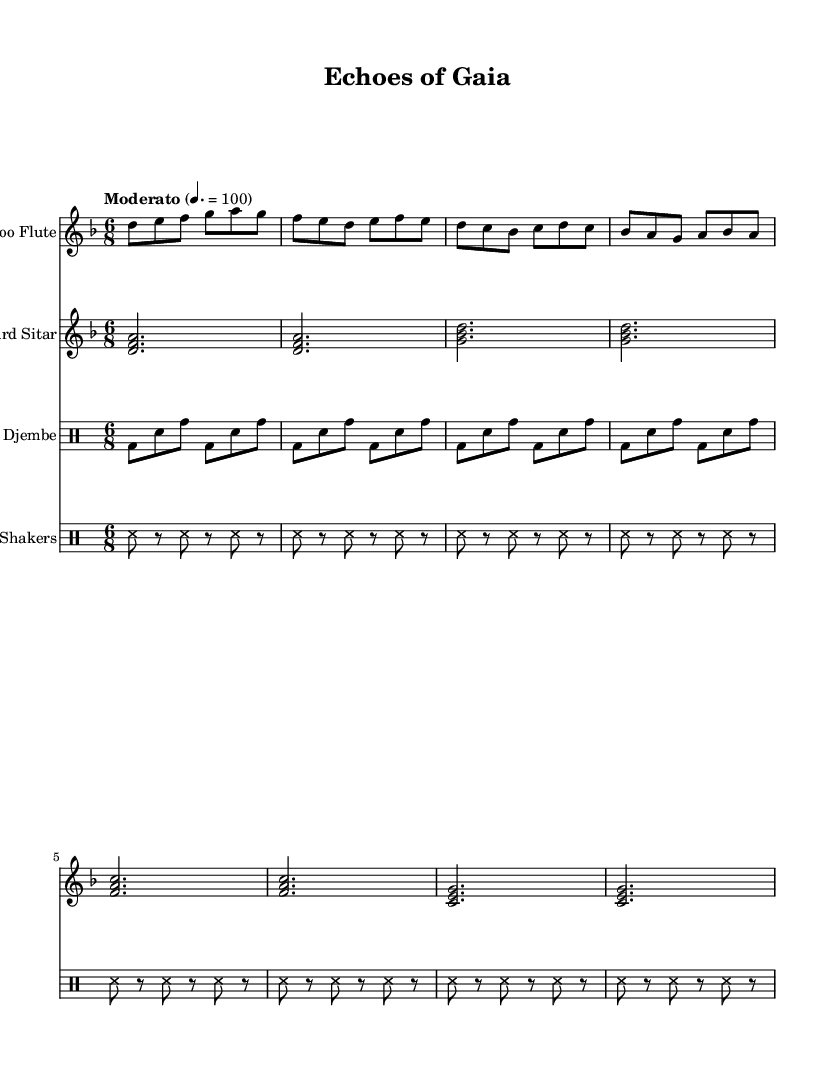What is the key signature of this music? The key signature is indicated at the beginning of the score, and it shows one flat (B♭). This identifies the key as D minor.
Answer: D minor What is the time signature of this music? The time signature is shown at the beginning of the score as 6/8, which means there are 6 beats per measure with an eighth note receiving one beat.
Answer: 6/8 What tempo marking is used in this piece? The tempo marking is located next to the global setup and reads "Moderato" with a metronome marking of 100 beats per minute, indicating the speed of the piece.
Answer: Moderato 4. = 100 How many different instruments are featured in this score? By counting the number of unique staves in the score section, we find four instruments: Bamboo Flute, Gourd Sitar, Clay Djembe, and Coconut Shell Shakers.
Answer: Four What instrument plays the harmony in this composition? The Gourd Sitar plays the harmony, as indicated by the chord structures (like <d f a>) present in its staff, which provide a harmonic foundation.
Answer: Gourd Sitar How does the rhythm of the bamboo flute differ from the rhythm of the clay djembe? The bamboo flute has a melodic rhythm with varied note lengths, while the clay djembe maintains a consistent rhythmic pattern primarily using bass and snare hits that create a stable beat.
Answer: Melodic vs. Rhythmic What is the function of the coconut shell shakers in this piece? The coconut shell shakers provide a percussive texture through consistent interspersed shaking, adding rhythmic interest and enhancing the overall sound without taking focus away from the melodic instruments.
Answer: Textural enhancement 